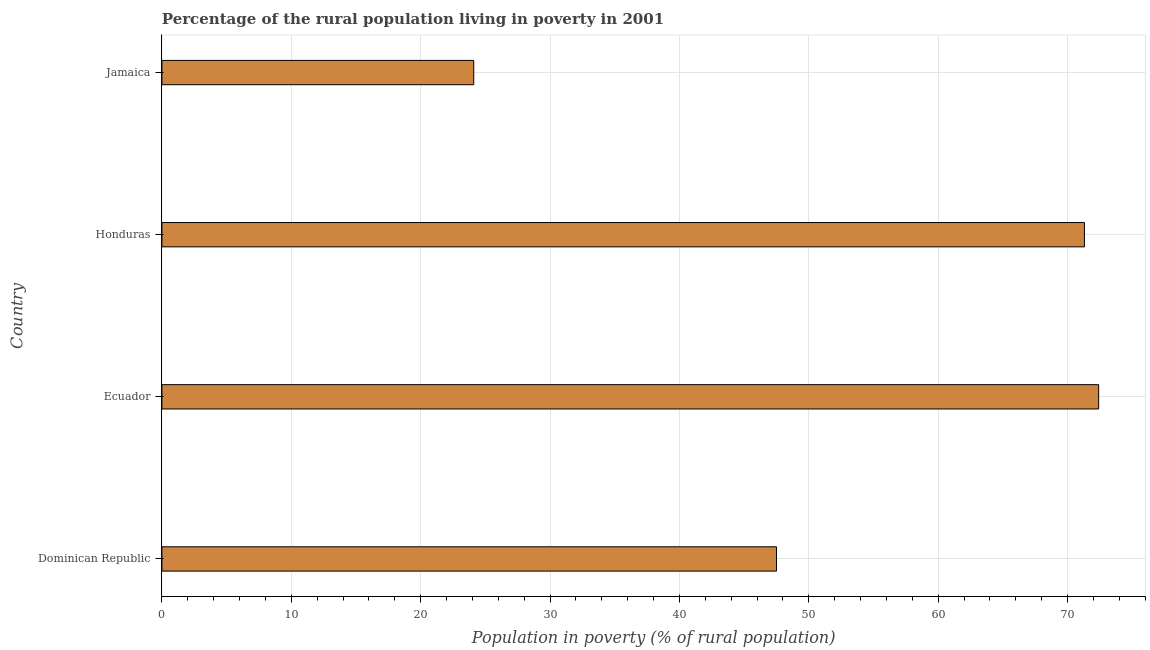What is the title of the graph?
Give a very brief answer. Percentage of the rural population living in poverty in 2001. What is the label or title of the X-axis?
Your answer should be compact. Population in poverty (% of rural population). What is the percentage of rural population living below poverty line in Dominican Republic?
Make the answer very short. 47.5. Across all countries, what is the maximum percentage of rural population living below poverty line?
Your answer should be very brief. 72.4. Across all countries, what is the minimum percentage of rural population living below poverty line?
Your answer should be very brief. 24.1. In which country was the percentage of rural population living below poverty line maximum?
Offer a very short reply. Ecuador. In which country was the percentage of rural population living below poverty line minimum?
Keep it short and to the point. Jamaica. What is the sum of the percentage of rural population living below poverty line?
Give a very brief answer. 215.3. What is the difference between the percentage of rural population living below poverty line in Ecuador and Jamaica?
Your answer should be very brief. 48.3. What is the average percentage of rural population living below poverty line per country?
Make the answer very short. 53.83. What is the median percentage of rural population living below poverty line?
Your answer should be very brief. 59.4. Is the percentage of rural population living below poverty line in Ecuador less than that in Jamaica?
Your answer should be compact. No. Is the difference between the percentage of rural population living below poverty line in Dominican Republic and Honduras greater than the difference between any two countries?
Make the answer very short. No. What is the difference between the highest and the second highest percentage of rural population living below poverty line?
Provide a succinct answer. 1.1. Is the sum of the percentage of rural population living below poverty line in Dominican Republic and Jamaica greater than the maximum percentage of rural population living below poverty line across all countries?
Give a very brief answer. No. What is the difference between the highest and the lowest percentage of rural population living below poverty line?
Provide a short and direct response. 48.3. How many bars are there?
Your answer should be very brief. 4. What is the difference between two consecutive major ticks on the X-axis?
Make the answer very short. 10. What is the Population in poverty (% of rural population) in Dominican Republic?
Make the answer very short. 47.5. What is the Population in poverty (% of rural population) in Ecuador?
Make the answer very short. 72.4. What is the Population in poverty (% of rural population) of Honduras?
Offer a very short reply. 71.3. What is the Population in poverty (% of rural population) in Jamaica?
Offer a terse response. 24.1. What is the difference between the Population in poverty (% of rural population) in Dominican Republic and Ecuador?
Your answer should be compact. -24.9. What is the difference between the Population in poverty (% of rural population) in Dominican Republic and Honduras?
Keep it short and to the point. -23.8. What is the difference between the Population in poverty (% of rural population) in Dominican Republic and Jamaica?
Provide a succinct answer. 23.4. What is the difference between the Population in poverty (% of rural population) in Ecuador and Honduras?
Give a very brief answer. 1.1. What is the difference between the Population in poverty (% of rural population) in Ecuador and Jamaica?
Provide a short and direct response. 48.3. What is the difference between the Population in poverty (% of rural population) in Honduras and Jamaica?
Make the answer very short. 47.2. What is the ratio of the Population in poverty (% of rural population) in Dominican Republic to that in Ecuador?
Ensure brevity in your answer.  0.66. What is the ratio of the Population in poverty (% of rural population) in Dominican Republic to that in Honduras?
Ensure brevity in your answer.  0.67. What is the ratio of the Population in poverty (% of rural population) in Dominican Republic to that in Jamaica?
Your response must be concise. 1.97. What is the ratio of the Population in poverty (% of rural population) in Ecuador to that in Jamaica?
Your response must be concise. 3. What is the ratio of the Population in poverty (% of rural population) in Honduras to that in Jamaica?
Your answer should be compact. 2.96. 